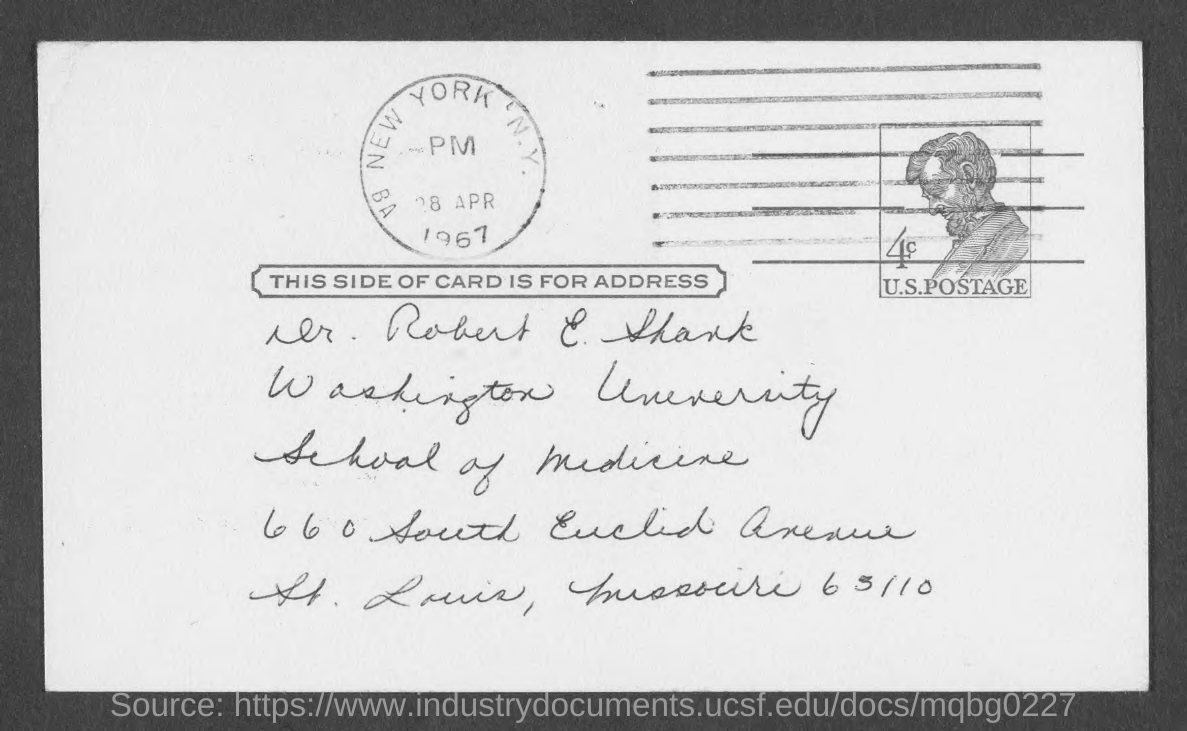Give some essential details in this illustration. The date mentioned on the postage stamp is April 28, 1967. The address given contains the mention of Washington University. 